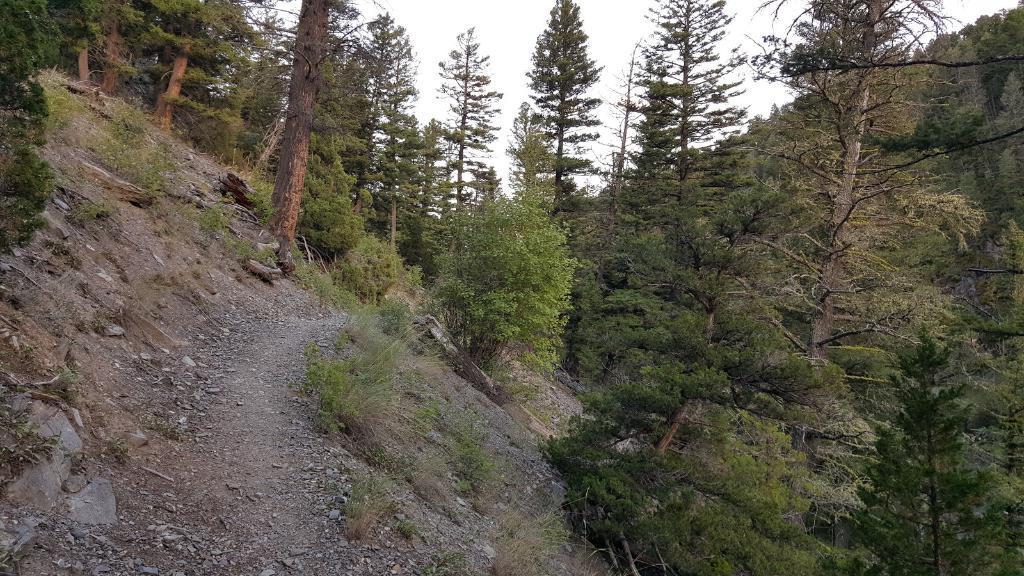In one or two sentences, can you explain what this image depicts? In this image we can see trees and grass, we can see the stones, at the top we can see the sky. 